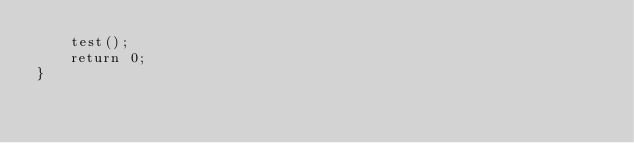<code> <loc_0><loc_0><loc_500><loc_500><_C++_>    test();
    return 0;
}
</code> 